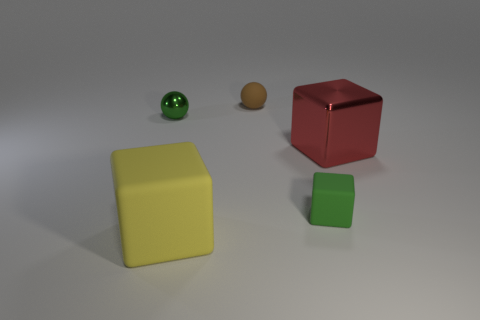Add 1 metallic balls. How many objects exist? 6 Subtract all cubes. How many objects are left? 2 Subtract 0 green cylinders. How many objects are left? 5 Subtract all matte things. Subtract all big red shiny cubes. How many objects are left? 1 Add 3 large cubes. How many large cubes are left? 5 Add 2 large blue matte cylinders. How many large blue matte cylinders exist? 2 